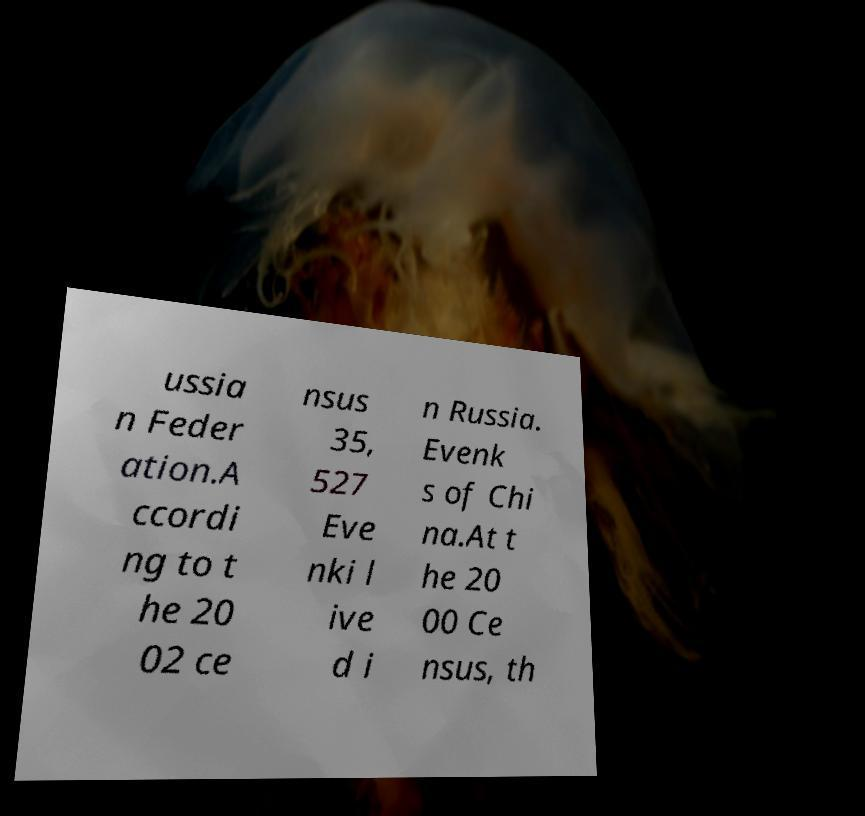Could you assist in decoding the text presented in this image and type it out clearly? ussia n Feder ation.A ccordi ng to t he 20 02 ce nsus 35, 527 Eve nki l ive d i n Russia. Evenk s of Chi na.At t he 20 00 Ce nsus, th 